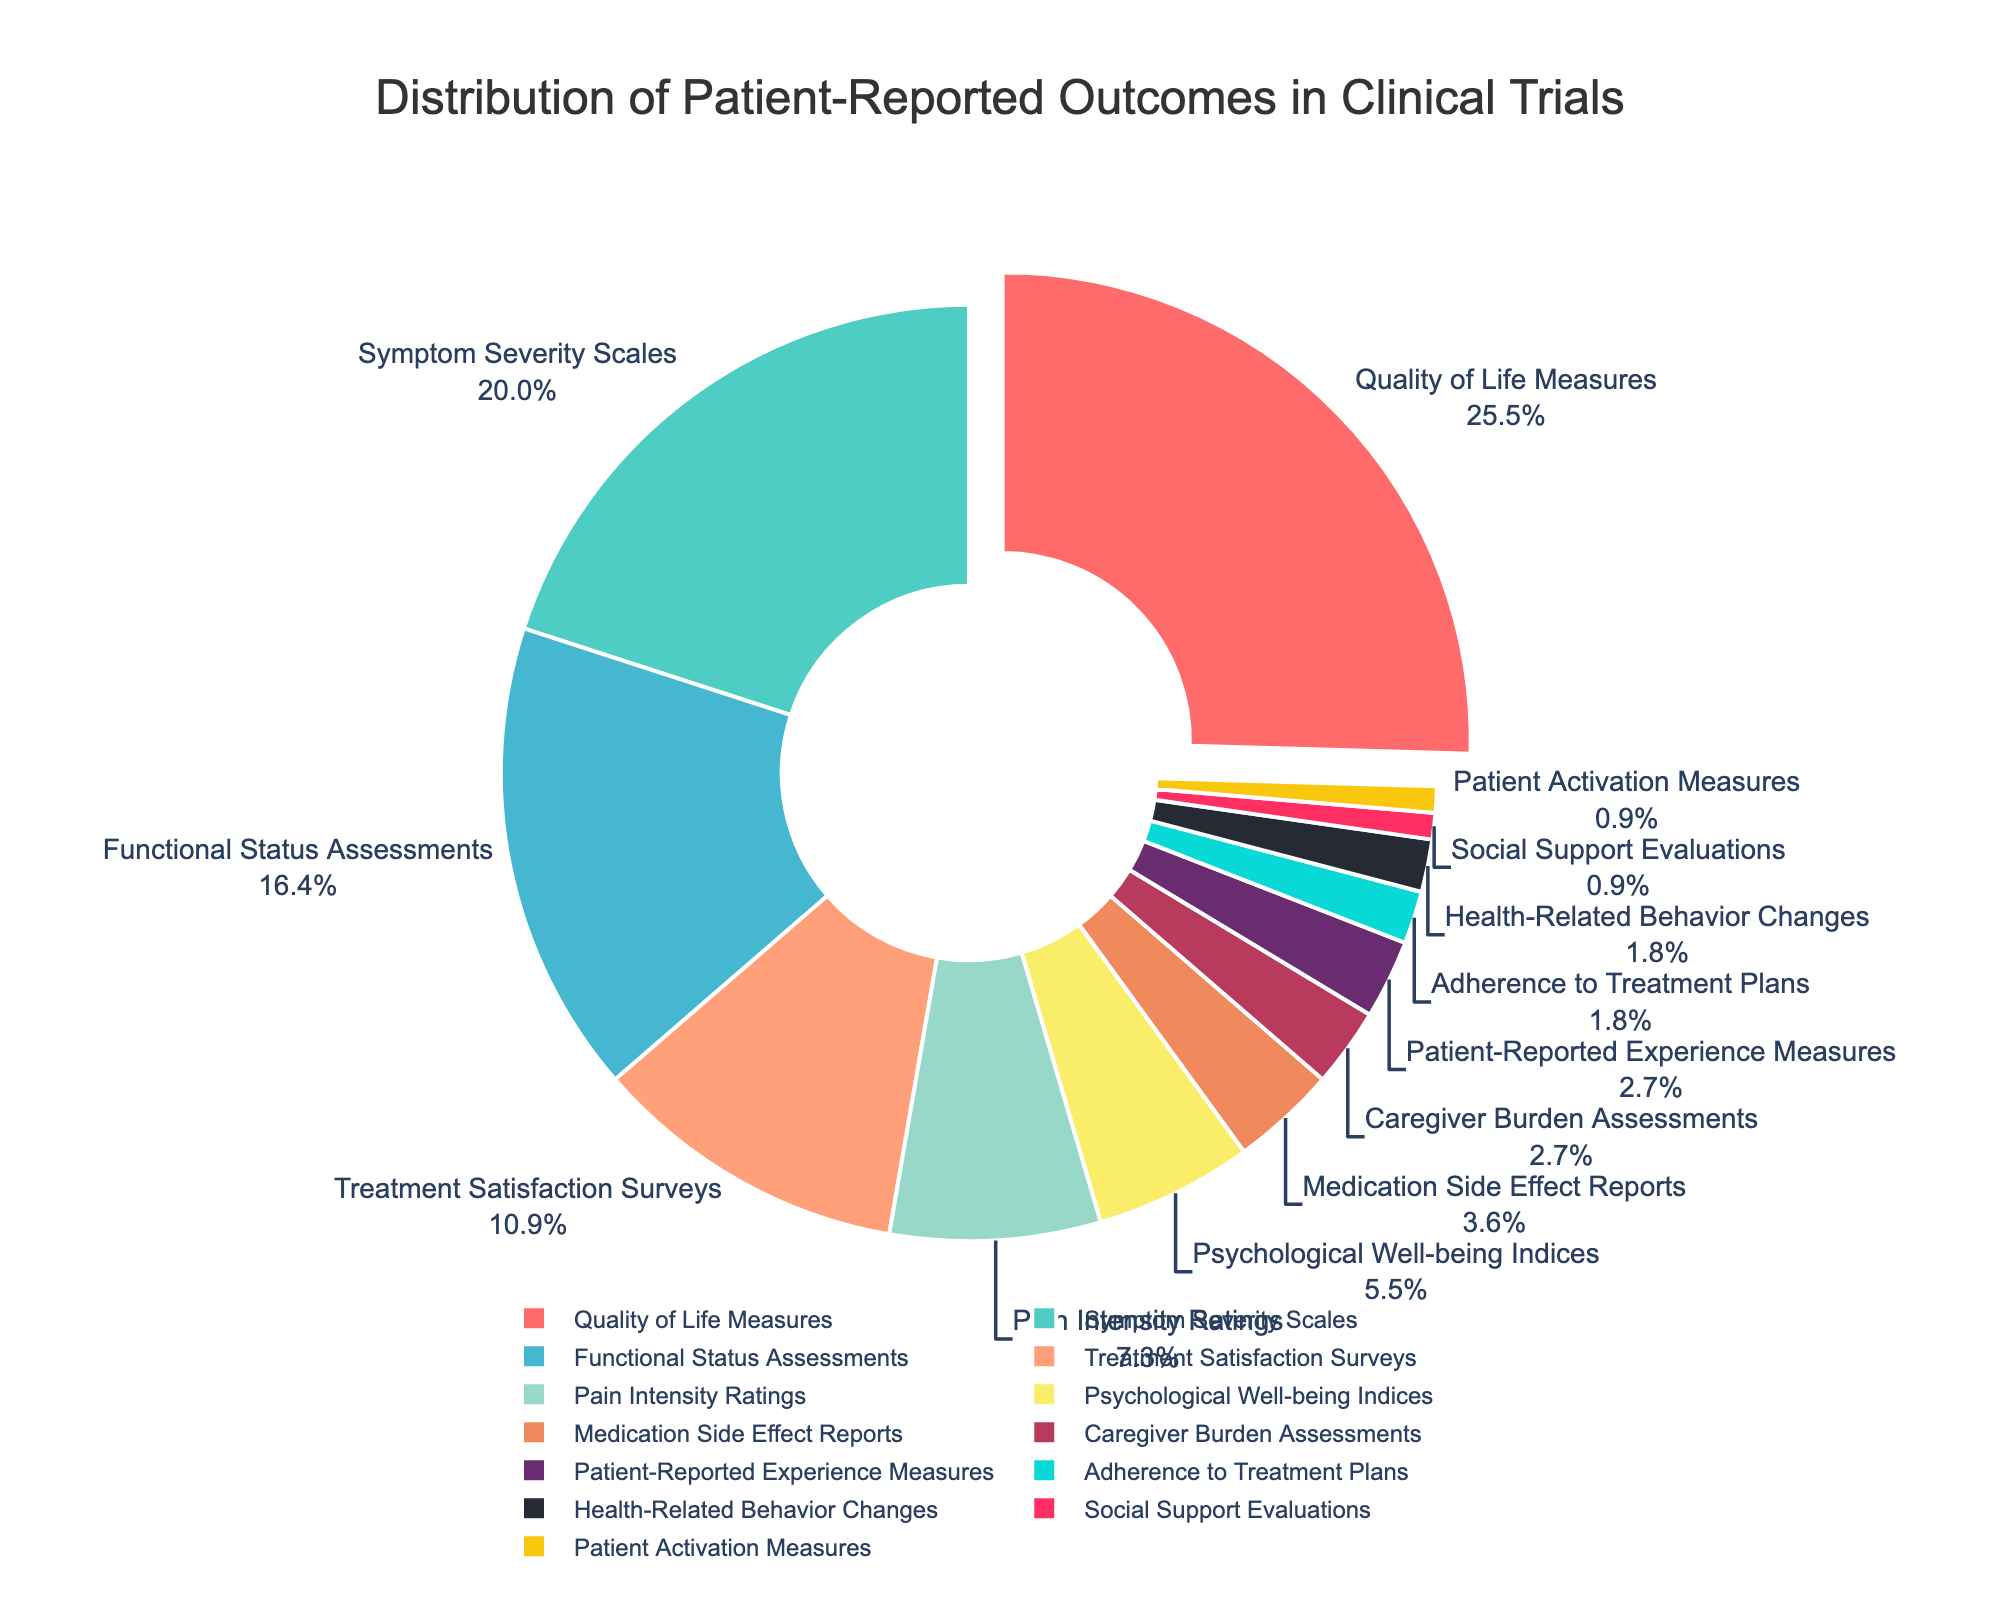What category represents the largest portion of patient-reported outcomes? The figure is a pie chart with different categories and their corresponding percentages. The biggest slice, which is also pulled out for emphasis, is labeled "Quality of Life Measures" and represents 28%.
Answer: Quality of Life Measures Which categories together constitute over 50% of the patient-reported outcomes? By combining the categories and their percentages, we find the following: Quality of Life Measures (28%) + Symptom Severity Scales (22%). Together, these make 50%, which is exactly half. Adding the next category would exceed 50%.
Answer: Quality of Life Measures and Symptom Severity Scales Are there more categories with less than 5% or more than 5% of patient-reported outcomes? There are several categories with percentages less or equal to 5%: Medication Side Effect Reports (4%), Caregiver Burden Assessments (3%), Patient-Reported Experience Measures (3%), Adherence to Treatment Plans (2%), Health-Related Behavior Changes (2%), Social Support Evaluations (1%), and Patient Activation Measures (1%). Counting these, we have 7 categories with less than or equal to 5%. Categories with more than 5% are: Quality of Life Measures (28%), Symptom Severity Scales (22%), Functional Status Assessments (18%), Treatment Satisfaction Surveys (12%), Pain Intensity Ratings (8%), and Psychological Well-being Indices (6%), totaling 6 categories. Thus, more categories have less than or equal to 5% of the patient-reported outcomes.
Answer: Less than 5% What percentage of patient-reported outcomes are related to functional status and treatment satisfaction? The percentages for Functional Status Assessments (18%) and Treatment Satisfaction Surveys (12%) need to be added together: 18% + 12% = 30%.
Answer: 30% Which category has the smallest proportion of patient-reported outcomes, and what is its percentage? The smallest portion in the pie chart, identified by the smallest slice, is "Patient Activation Measures," which is labeled as 1%.
Answer: Patient Activation Measures Is the percentage for Pain Intensity Ratings greater than the combined percentage for Social Support Evaluations and Adherence to Treatment Plans? Consider the percentage for Pain Intensity Ratings, which is 8%. The combined percentage for Social Support Evaluations (1%) and Adherence to Treatment Plans (2%) is 1% + 2% = 3%. 8% is greater than 3%.
Answer: Yes What is the combined percentage of Symptom Severity Scales and Psychological Well-being Indices, and how does it compare to Quality of Life Measures? The percentages for Symptom Severity Scales (22%) and Psychological Well-being Indices (6%) need to be summed: 22% + 6% = 28%. This matches the percentage for Quality of Life Measures, which is also 28%, meaning they are equal.
Answer: 28%, equal to Quality of Life Measures 